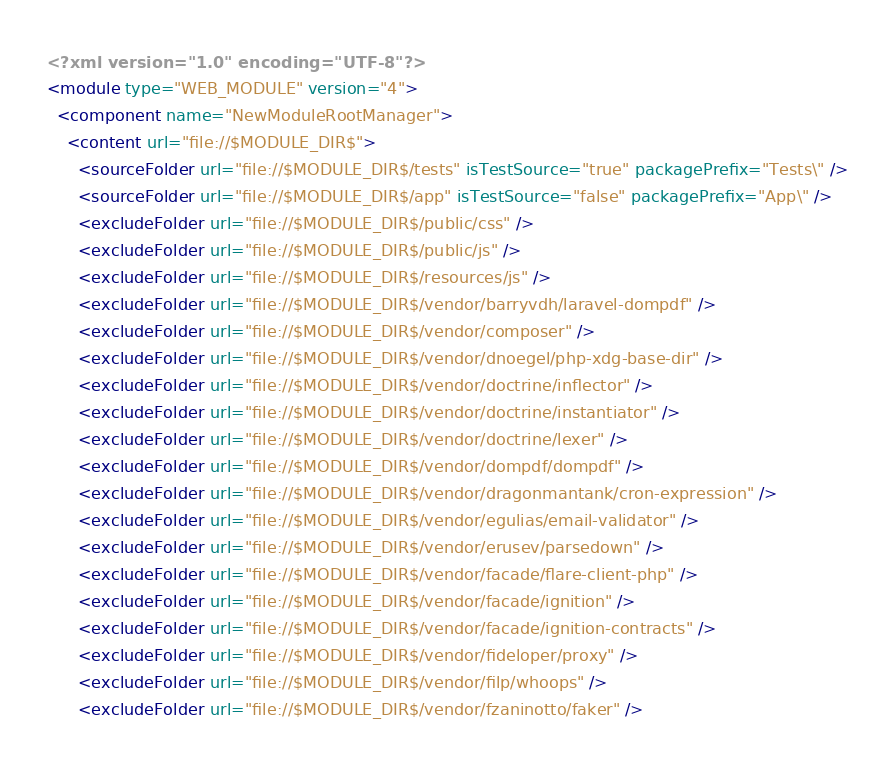<code> <loc_0><loc_0><loc_500><loc_500><_XML_><?xml version="1.0" encoding="UTF-8"?>
<module type="WEB_MODULE" version="4">
  <component name="NewModuleRootManager">
    <content url="file://$MODULE_DIR$">
      <sourceFolder url="file://$MODULE_DIR$/tests" isTestSource="true" packagePrefix="Tests\" />
      <sourceFolder url="file://$MODULE_DIR$/app" isTestSource="false" packagePrefix="App\" />
      <excludeFolder url="file://$MODULE_DIR$/public/css" />
      <excludeFolder url="file://$MODULE_DIR$/public/js" />
      <excludeFolder url="file://$MODULE_DIR$/resources/js" />
      <excludeFolder url="file://$MODULE_DIR$/vendor/barryvdh/laravel-dompdf" />
      <excludeFolder url="file://$MODULE_DIR$/vendor/composer" />
      <excludeFolder url="file://$MODULE_DIR$/vendor/dnoegel/php-xdg-base-dir" />
      <excludeFolder url="file://$MODULE_DIR$/vendor/doctrine/inflector" />
      <excludeFolder url="file://$MODULE_DIR$/vendor/doctrine/instantiator" />
      <excludeFolder url="file://$MODULE_DIR$/vendor/doctrine/lexer" />
      <excludeFolder url="file://$MODULE_DIR$/vendor/dompdf/dompdf" />
      <excludeFolder url="file://$MODULE_DIR$/vendor/dragonmantank/cron-expression" />
      <excludeFolder url="file://$MODULE_DIR$/vendor/egulias/email-validator" />
      <excludeFolder url="file://$MODULE_DIR$/vendor/erusev/parsedown" />
      <excludeFolder url="file://$MODULE_DIR$/vendor/facade/flare-client-php" />
      <excludeFolder url="file://$MODULE_DIR$/vendor/facade/ignition" />
      <excludeFolder url="file://$MODULE_DIR$/vendor/facade/ignition-contracts" />
      <excludeFolder url="file://$MODULE_DIR$/vendor/fideloper/proxy" />
      <excludeFolder url="file://$MODULE_DIR$/vendor/filp/whoops" />
      <excludeFolder url="file://$MODULE_DIR$/vendor/fzaninotto/faker" /></code> 